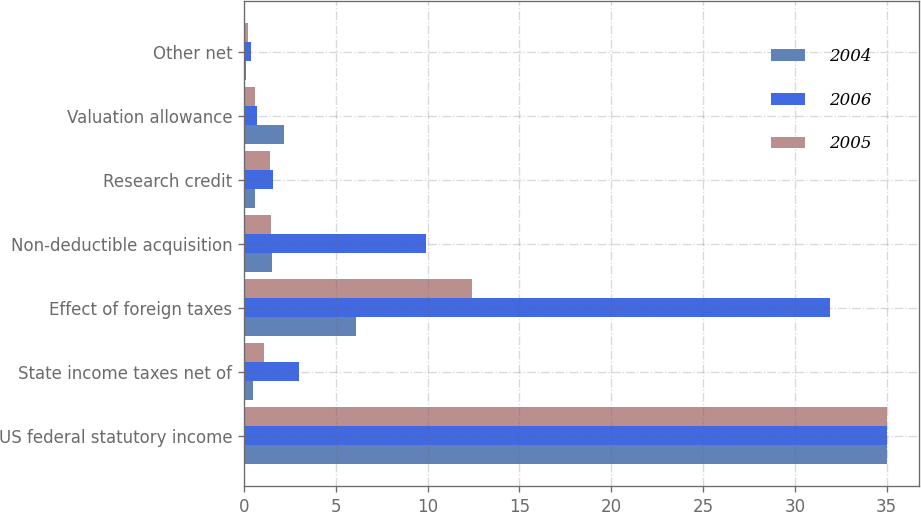Convert chart. <chart><loc_0><loc_0><loc_500><loc_500><stacked_bar_chart><ecel><fcel>US federal statutory income<fcel>State income taxes net of<fcel>Effect of foreign taxes<fcel>Non-deductible acquisition<fcel>Research credit<fcel>Valuation allowance<fcel>Other net<nl><fcel>2004<fcel>35<fcel>0.5<fcel>6.1<fcel>1.55<fcel>0.6<fcel>2.2<fcel>0.1<nl><fcel>2006<fcel>35<fcel>3<fcel>31.9<fcel>9.9<fcel>1.6<fcel>0.7<fcel>0.4<nl><fcel>2005<fcel>35<fcel>1.1<fcel>12.4<fcel>1.5<fcel>1.4<fcel>0.6<fcel>0.2<nl></chart> 